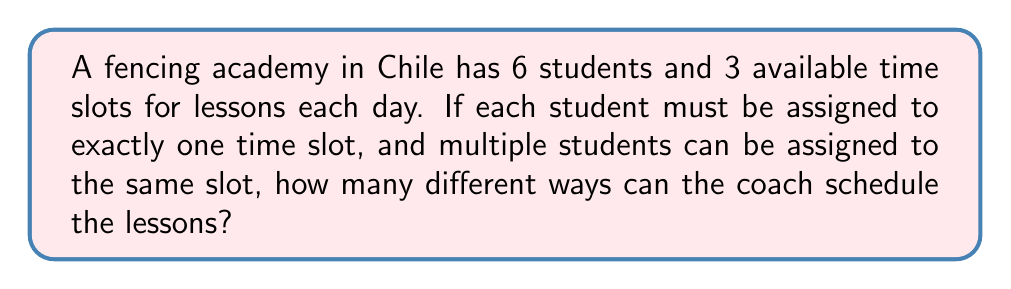Solve this math problem. Let's approach this step-by-step:

1) This is a problem of distributing distinct objects (students) into distinct boxes (time slots).

2) Each student has 3 choices for their time slot, independent of the other students' choices.

3) We can use the multiplication principle here. For each student:
   - The first student has 3 choices
   - The second student has 3 choices
   - ...and so on for all 6 students

4) Therefore, the total number of ways to schedule the lessons is:

   $$3 \times 3 \times 3 \times 3 \times 3 \times 3 = 3^6$$

5) We can calculate this:
   
   $$3^6 = 3 \times 3 \times 3 \times 3 \times 3 \times 3 = 729$$

Thus, there are 729 different ways to schedule the fencing lessons.
Answer: $3^6 = 729$ 